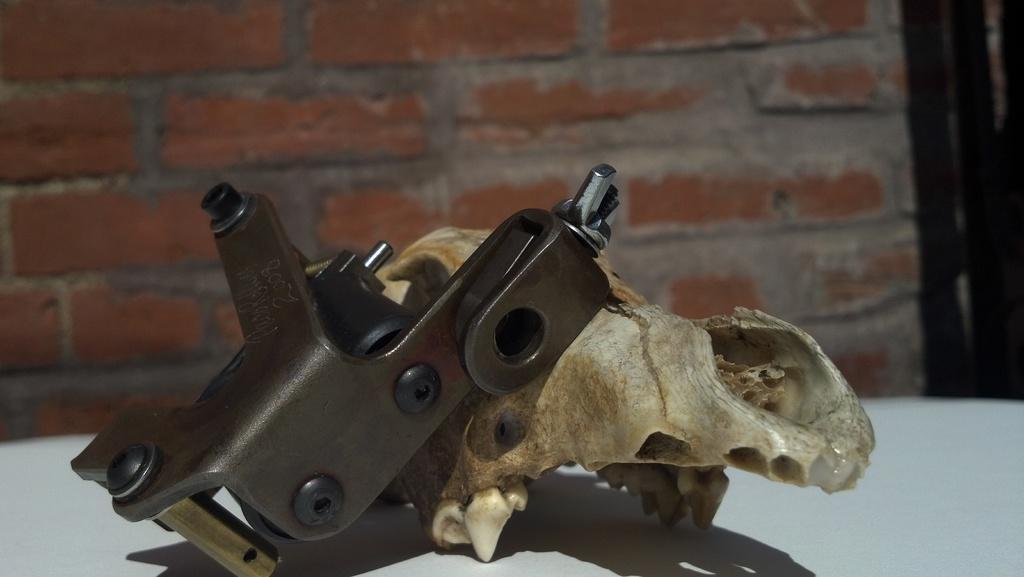Describe this image in one or two sentences. In this image there is a table, on that table there is a skull of an animal and an iron object, in the background there is a wall. 